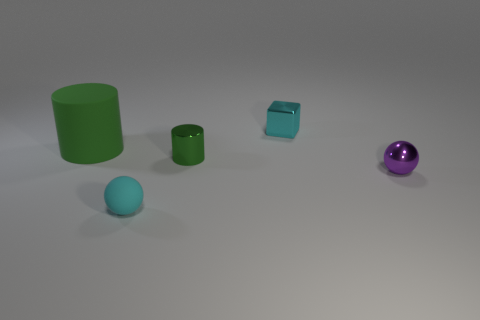Subtract all cylinders. How many objects are left? 3 Add 5 tiny purple balls. How many tiny purple balls are left? 6 Add 4 green matte cylinders. How many green matte cylinders exist? 5 Add 3 big purple shiny balls. How many objects exist? 8 Subtract 0 yellow blocks. How many objects are left? 5 Subtract 1 cubes. How many cubes are left? 0 Subtract all gray blocks. Subtract all cyan spheres. How many blocks are left? 1 Subtract all purple cubes. How many green spheres are left? 0 Subtract all small balls. Subtract all rubber things. How many objects are left? 1 